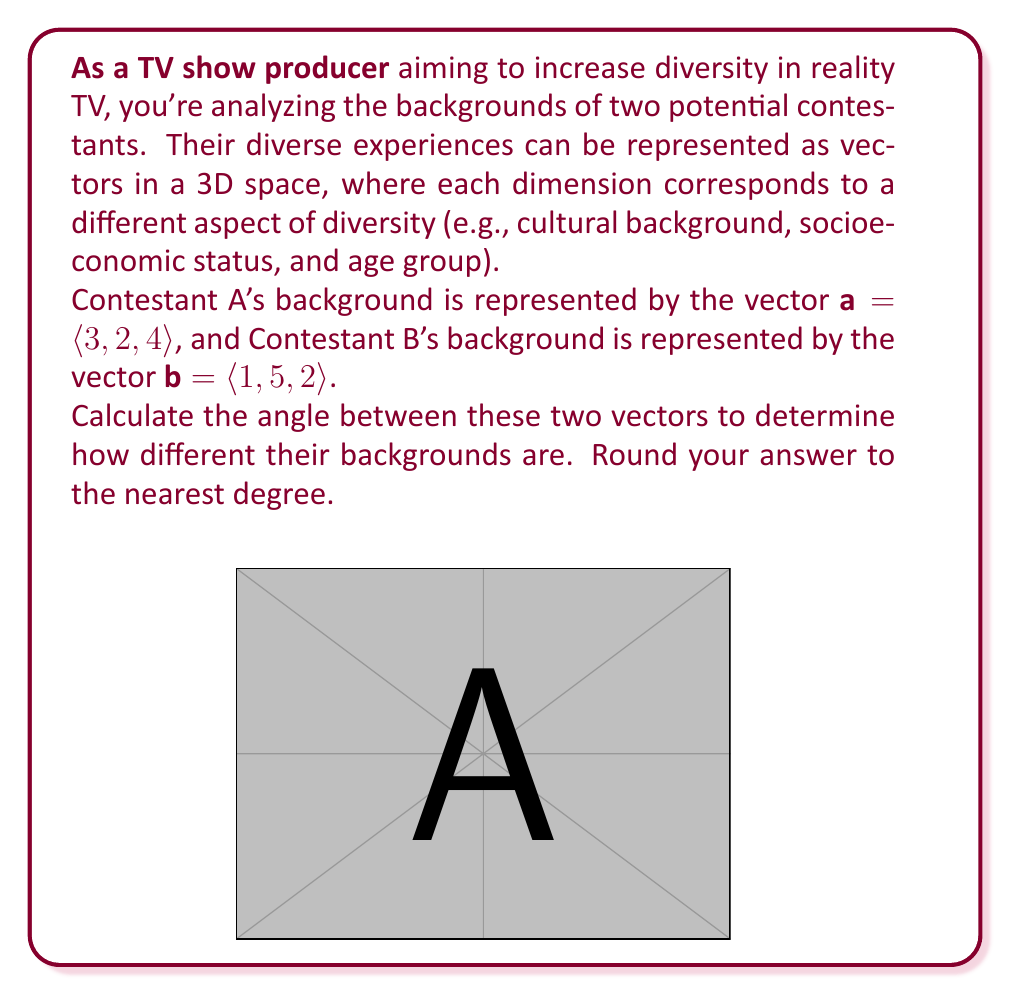Show me your answer to this math problem. To find the angle between two vectors, we can use the dot product formula:

$$\cos \theta = \frac{\mathbf{a} \cdot \mathbf{b}}{|\mathbf{a}||\mathbf{b}|}$$

Let's solve this step by step:

1) First, calculate the dot product $\mathbf{a} \cdot \mathbf{b}$:
   $$\mathbf{a} \cdot \mathbf{b} = (3)(1) + (2)(5) + (4)(2) = 3 + 10 + 8 = 21$$

2) Calculate the magnitudes of the vectors:
   $$|\mathbf{a}| = \sqrt{3^2 + 2^2 + 4^2} = \sqrt{9 + 4 + 16} = \sqrt{29}$$
   $$|\mathbf{b}| = \sqrt{1^2 + 5^2 + 2^2} = \sqrt{1 + 25 + 4} = \sqrt{30}$$

3) Now, substitute these values into the formula:
   $$\cos \theta = \frac{21}{\sqrt{29}\sqrt{30}}$$

4) Simplify:
   $$\cos \theta = \frac{21}{\sqrt{870}}$$

5) To find $\theta$, take the inverse cosine (arccos) of both sides:
   $$\theta = \arccos(\frac{21}{\sqrt{870}})$$

6) Calculate this value and convert to degrees:
   $$\theta \approx 44.4150^\circ$$

7) Rounding to the nearest degree:
   $$\theta \approx 44^\circ$$

This angle represents the difference in backgrounds between the two contestants. A smaller angle would indicate more similar backgrounds, while a larger angle would indicate more diverse backgrounds.
Answer: 44° 